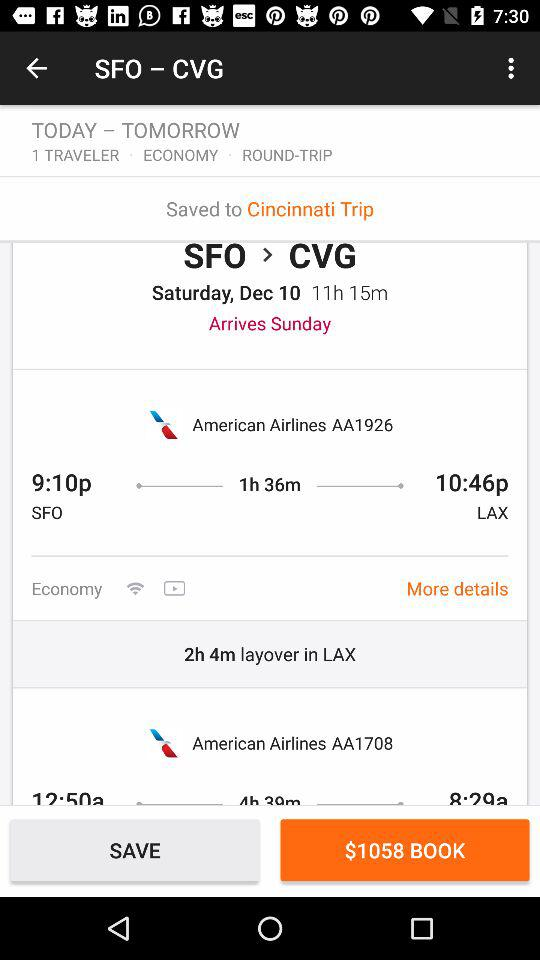How long is the layover in Los Angeles? The layover is for 2 hours 4 minutes. 